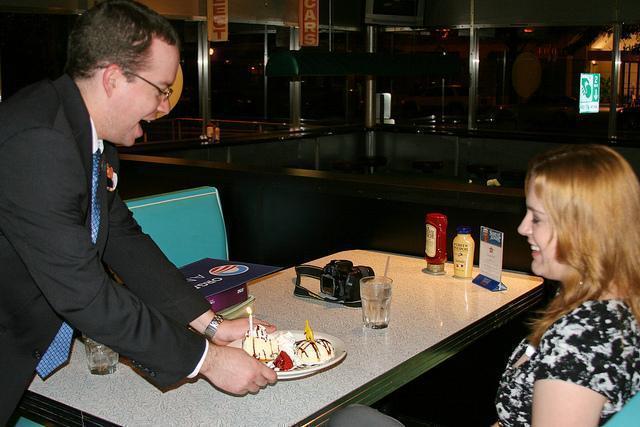Why is there a candle in the woman's dessert?
Pick the right solution, then justify: 'Answer: answer
Rationale: rationale.'
Options: To trick, to celebrate, as joke, for light. Answer: to celebrate.
Rationale: Candles placed in desserts are a traditional way to commemorate a special day or achievement. 